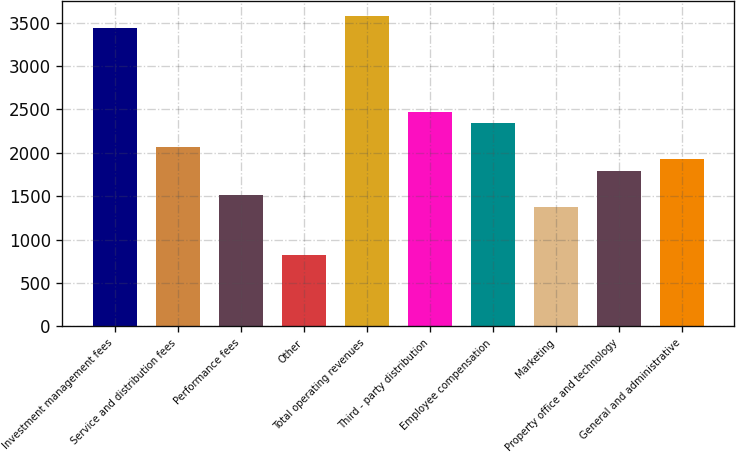<chart> <loc_0><loc_0><loc_500><loc_500><bar_chart><fcel>Investment management fees<fcel>Service and distribution fees<fcel>Performance fees<fcel>Other<fcel>Total operating revenues<fcel>Third - party distribution<fcel>Employee compensation<fcel>Marketing<fcel>Property office and technology<fcel>General and administrative<nl><fcel>3438.54<fcel>2063.24<fcel>1513.12<fcel>825.47<fcel>3576.07<fcel>2475.83<fcel>2338.3<fcel>1375.59<fcel>1788.18<fcel>1925.71<nl></chart> 